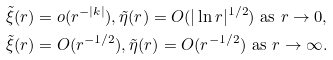<formula> <loc_0><loc_0><loc_500><loc_500>& \tilde { \xi } ( r ) = o ( r ^ { - | k | } ) , \tilde { \eta } ( r ) = O ( | \ln r | ^ { 1 / 2 } ) \text { as } r \rightarrow 0 , \\ & \tilde { \xi } ( r ) = O ( r ^ { - 1 / 2 } ) , \tilde { \eta } ( r ) = O ( r ^ { - 1 / 2 } ) \text { as } r \rightarrow \infty .</formula> 